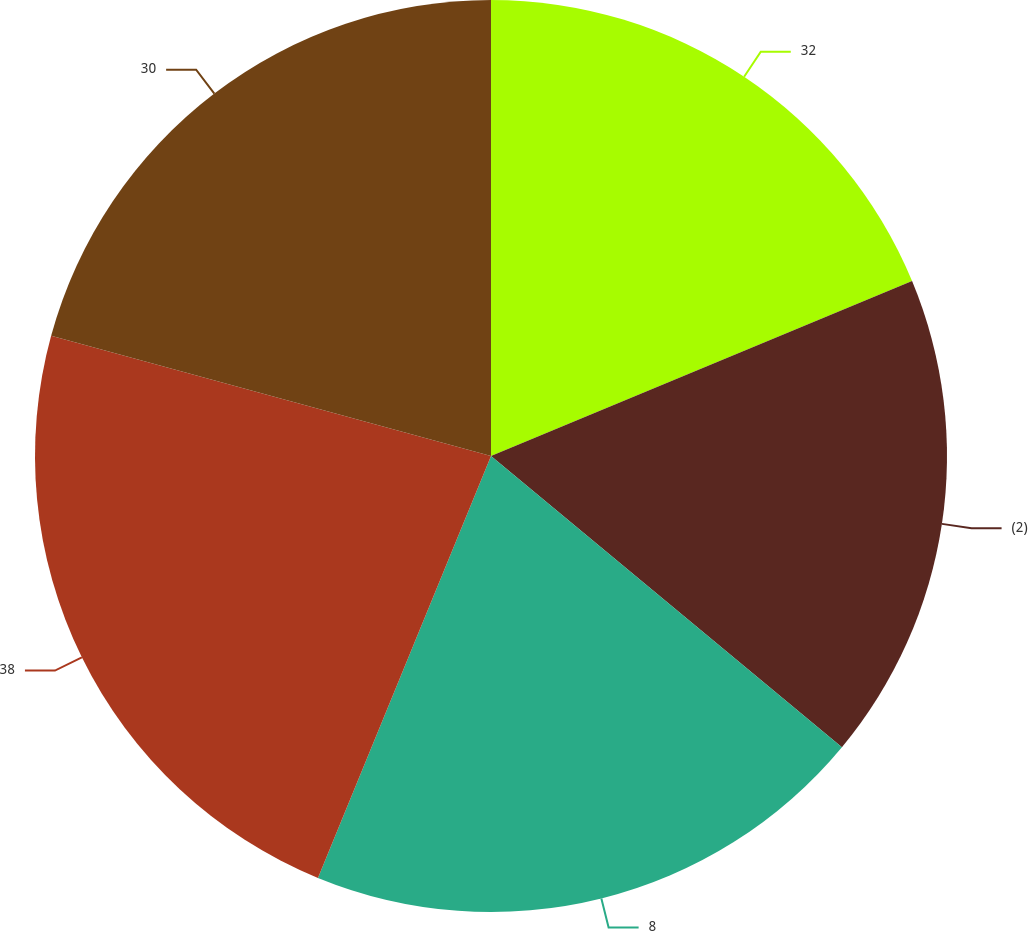<chart> <loc_0><loc_0><loc_500><loc_500><pie_chart><fcel>32<fcel>(2)<fcel>8<fcel>38<fcel>30<nl><fcel>18.73%<fcel>17.29%<fcel>20.17%<fcel>23.05%<fcel>20.75%<nl></chart> 